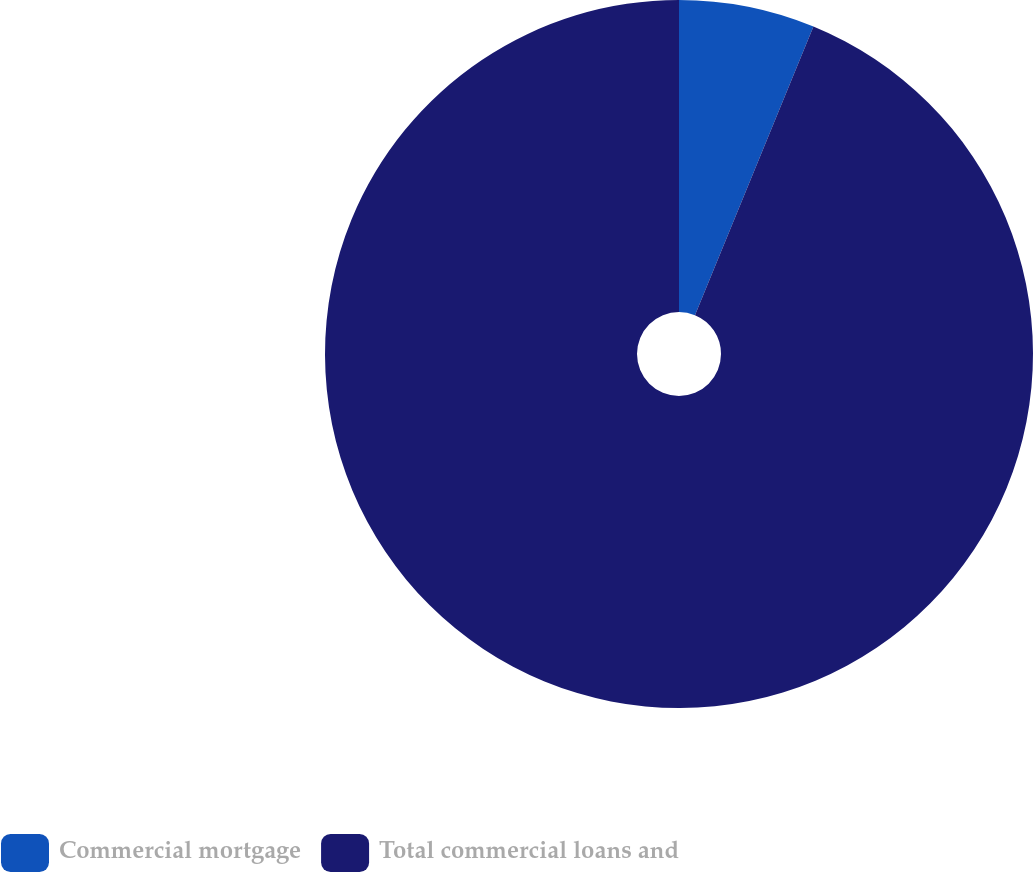<chart> <loc_0><loc_0><loc_500><loc_500><pie_chart><fcel>Commercial mortgage<fcel>Total commercial loans and<nl><fcel>6.2%<fcel>93.8%<nl></chart> 